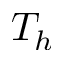Convert formula to latex. <formula><loc_0><loc_0><loc_500><loc_500>T _ { h }</formula> 